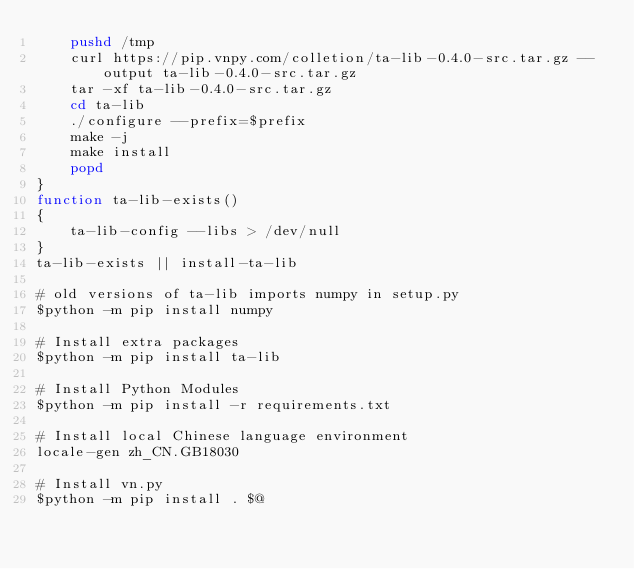<code> <loc_0><loc_0><loc_500><loc_500><_Bash_>    pushd /tmp
    curl https://pip.vnpy.com/colletion/ta-lib-0.4.0-src.tar.gz --output ta-lib-0.4.0-src.tar.gz
    tar -xf ta-lib-0.4.0-src.tar.gz
    cd ta-lib
    ./configure --prefix=$prefix
    make -j
    make install
    popd
}
function ta-lib-exists()
{
    ta-lib-config --libs > /dev/null
}
ta-lib-exists || install-ta-lib

# old versions of ta-lib imports numpy in setup.py
$python -m pip install numpy

# Install extra packages
$python -m pip install ta-lib

# Install Python Modules
$python -m pip install -r requirements.txt

# Install local Chinese language environment
locale-gen zh_CN.GB18030

# Install vn.py
$python -m pip install . $@</code> 